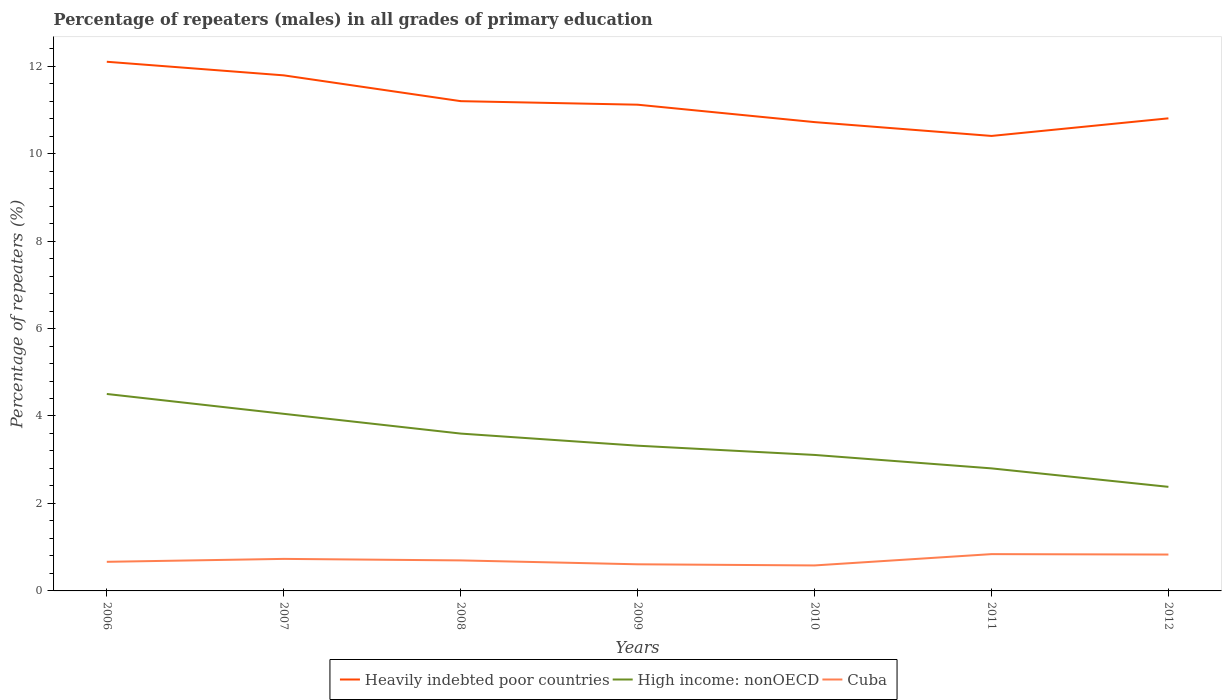Across all years, what is the maximum percentage of repeaters (males) in Cuba?
Your response must be concise. 0.58. In which year was the percentage of repeaters (males) in Cuba maximum?
Provide a short and direct response. 2010. What is the total percentage of repeaters (males) in High income: nonOECD in the graph?
Your answer should be very brief. 1.22. What is the difference between the highest and the second highest percentage of repeaters (males) in Cuba?
Give a very brief answer. 0.26. What is the difference between the highest and the lowest percentage of repeaters (males) in Cuba?
Provide a short and direct response. 3. Is the percentage of repeaters (males) in High income: nonOECD strictly greater than the percentage of repeaters (males) in Heavily indebted poor countries over the years?
Make the answer very short. Yes. Are the values on the major ticks of Y-axis written in scientific E-notation?
Provide a succinct answer. No. Where does the legend appear in the graph?
Your answer should be compact. Bottom center. What is the title of the graph?
Provide a succinct answer. Percentage of repeaters (males) in all grades of primary education. Does "San Marino" appear as one of the legend labels in the graph?
Ensure brevity in your answer.  No. What is the label or title of the X-axis?
Your answer should be compact. Years. What is the label or title of the Y-axis?
Provide a short and direct response. Percentage of repeaters (%). What is the Percentage of repeaters (%) of Heavily indebted poor countries in 2006?
Ensure brevity in your answer.  12.1. What is the Percentage of repeaters (%) in High income: nonOECD in 2006?
Give a very brief answer. 4.5. What is the Percentage of repeaters (%) in Cuba in 2006?
Ensure brevity in your answer.  0.67. What is the Percentage of repeaters (%) in Heavily indebted poor countries in 2007?
Provide a short and direct response. 11.79. What is the Percentage of repeaters (%) of High income: nonOECD in 2007?
Give a very brief answer. 4.05. What is the Percentage of repeaters (%) of Cuba in 2007?
Your answer should be very brief. 0.73. What is the Percentage of repeaters (%) of Heavily indebted poor countries in 2008?
Your answer should be very brief. 11.2. What is the Percentage of repeaters (%) of High income: nonOECD in 2008?
Your response must be concise. 3.6. What is the Percentage of repeaters (%) of Cuba in 2008?
Your answer should be very brief. 0.7. What is the Percentage of repeaters (%) in Heavily indebted poor countries in 2009?
Your answer should be very brief. 11.12. What is the Percentage of repeaters (%) in High income: nonOECD in 2009?
Ensure brevity in your answer.  3.32. What is the Percentage of repeaters (%) in Cuba in 2009?
Ensure brevity in your answer.  0.61. What is the Percentage of repeaters (%) in Heavily indebted poor countries in 2010?
Make the answer very short. 10.72. What is the Percentage of repeaters (%) in High income: nonOECD in 2010?
Give a very brief answer. 3.11. What is the Percentage of repeaters (%) in Cuba in 2010?
Ensure brevity in your answer.  0.58. What is the Percentage of repeaters (%) of Heavily indebted poor countries in 2011?
Give a very brief answer. 10.4. What is the Percentage of repeaters (%) of High income: nonOECD in 2011?
Provide a short and direct response. 2.8. What is the Percentage of repeaters (%) in Cuba in 2011?
Your answer should be very brief. 0.84. What is the Percentage of repeaters (%) in Heavily indebted poor countries in 2012?
Your response must be concise. 10.81. What is the Percentage of repeaters (%) of High income: nonOECD in 2012?
Your answer should be compact. 2.38. What is the Percentage of repeaters (%) in Cuba in 2012?
Provide a short and direct response. 0.83. Across all years, what is the maximum Percentage of repeaters (%) in Heavily indebted poor countries?
Your response must be concise. 12.1. Across all years, what is the maximum Percentage of repeaters (%) of High income: nonOECD?
Offer a terse response. 4.5. Across all years, what is the maximum Percentage of repeaters (%) of Cuba?
Offer a terse response. 0.84. Across all years, what is the minimum Percentage of repeaters (%) in Heavily indebted poor countries?
Your response must be concise. 10.4. Across all years, what is the minimum Percentage of repeaters (%) of High income: nonOECD?
Your response must be concise. 2.38. Across all years, what is the minimum Percentage of repeaters (%) in Cuba?
Give a very brief answer. 0.58. What is the total Percentage of repeaters (%) of Heavily indebted poor countries in the graph?
Make the answer very short. 78.14. What is the total Percentage of repeaters (%) of High income: nonOECD in the graph?
Give a very brief answer. 23.76. What is the total Percentage of repeaters (%) of Cuba in the graph?
Make the answer very short. 4.96. What is the difference between the Percentage of repeaters (%) in Heavily indebted poor countries in 2006 and that in 2007?
Keep it short and to the point. 0.31. What is the difference between the Percentage of repeaters (%) in High income: nonOECD in 2006 and that in 2007?
Ensure brevity in your answer.  0.45. What is the difference between the Percentage of repeaters (%) of Cuba in 2006 and that in 2007?
Your response must be concise. -0.07. What is the difference between the Percentage of repeaters (%) of Heavily indebted poor countries in 2006 and that in 2008?
Provide a succinct answer. 0.9. What is the difference between the Percentage of repeaters (%) of High income: nonOECD in 2006 and that in 2008?
Make the answer very short. 0.91. What is the difference between the Percentage of repeaters (%) in Cuba in 2006 and that in 2008?
Your response must be concise. -0.03. What is the difference between the Percentage of repeaters (%) in Heavily indebted poor countries in 2006 and that in 2009?
Keep it short and to the point. 0.98. What is the difference between the Percentage of repeaters (%) of High income: nonOECD in 2006 and that in 2009?
Your answer should be compact. 1.18. What is the difference between the Percentage of repeaters (%) of Cuba in 2006 and that in 2009?
Your response must be concise. 0.06. What is the difference between the Percentage of repeaters (%) in Heavily indebted poor countries in 2006 and that in 2010?
Your response must be concise. 1.38. What is the difference between the Percentage of repeaters (%) of High income: nonOECD in 2006 and that in 2010?
Offer a terse response. 1.39. What is the difference between the Percentage of repeaters (%) in Cuba in 2006 and that in 2010?
Offer a very short reply. 0.08. What is the difference between the Percentage of repeaters (%) in Heavily indebted poor countries in 2006 and that in 2011?
Give a very brief answer. 1.7. What is the difference between the Percentage of repeaters (%) in High income: nonOECD in 2006 and that in 2011?
Keep it short and to the point. 1.7. What is the difference between the Percentage of repeaters (%) of Cuba in 2006 and that in 2011?
Provide a succinct answer. -0.18. What is the difference between the Percentage of repeaters (%) in Heavily indebted poor countries in 2006 and that in 2012?
Make the answer very short. 1.29. What is the difference between the Percentage of repeaters (%) in High income: nonOECD in 2006 and that in 2012?
Your answer should be very brief. 2.12. What is the difference between the Percentage of repeaters (%) of Cuba in 2006 and that in 2012?
Your response must be concise. -0.17. What is the difference between the Percentage of repeaters (%) of Heavily indebted poor countries in 2007 and that in 2008?
Give a very brief answer. 0.59. What is the difference between the Percentage of repeaters (%) of High income: nonOECD in 2007 and that in 2008?
Keep it short and to the point. 0.45. What is the difference between the Percentage of repeaters (%) of Cuba in 2007 and that in 2008?
Provide a succinct answer. 0.03. What is the difference between the Percentage of repeaters (%) of Heavily indebted poor countries in 2007 and that in 2009?
Give a very brief answer. 0.67. What is the difference between the Percentage of repeaters (%) in High income: nonOECD in 2007 and that in 2009?
Offer a terse response. 0.73. What is the difference between the Percentage of repeaters (%) of Cuba in 2007 and that in 2009?
Provide a succinct answer. 0.12. What is the difference between the Percentage of repeaters (%) of Heavily indebted poor countries in 2007 and that in 2010?
Give a very brief answer. 1.07. What is the difference between the Percentage of repeaters (%) of High income: nonOECD in 2007 and that in 2010?
Give a very brief answer. 0.94. What is the difference between the Percentage of repeaters (%) of Cuba in 2007 and that in 2010?
Make the answer very short. 0.15. What is the difference between the Percentage of repeaters (%) of Heavily indebted poor countries in 2007 and that in 2011?
Provide a succinct answer. 1.39. What is the difference between the Percentage of repeaters (%) of High income: nonOECD in 2007 and that in 2011?
Your answer should be compact. 1.25. What is the difference between the Percentage of repeaters (%) of Cuba in 2007 and that in 2011?
Offer a very short reply. -0.11. What is the difference between the Percentage of repeaters (%) of High income: nonOECD in 2007 and that in 2012?
Your answer should be very brief. 1.67. What is the difference between the Percentage of repeaters (%) of Cuba in 2007 and that in 2012?
Your answer should be compact. -0.1. What is the difference between the Percentage of repeaters (%) in Heavily indebted poor countries in 2008 and that in 2009?
Make the answer very short. 0.08. What is the difference between the Percentage of repeaters (%) of High income: nonOECD in 2008 and that in 2009?
Ensure brevity in your answer.  0.28. What is the difference between the Percentage of repeaters (%) of Cuba in 2008 and that in 2009?
Offer a terse response. 0.09. What is the difference between the Percentage of repeaters (%) of Heavily indebted poor countries in 2008 and that in 2010?
Offer a terse response. 0.48. What is the difference between the Percentage of repeaters (%) of High income: nonOECD in 2008 and that in 2010?
Offer a terse response. 0.49. What is the difference between the Percentage of repeaters (%) in Cuba in 2008 and that in 2010?
Provide a short and direct response. 0.12. What is the difference between the Percentage of repeaters (%) of Heavily indebted poor countries in 2008 and that in 2011?
Offer a terse response. 0.8. What is the difference between the Percentage of repeaters (%) in High income: nonOECD in 2008 and that in 2011?
Ensure brevity in your answer.  0.8. What is the difference between the Percentage of repeaters (%) in Cuba in 2008 and that in 2011?
Give a very brief answer. -0.14. What is the difference between the Percentage of repeaters (%) of Heavily indebted poor countries in 2008 and that in 2012?
Offer a terse response. 0.39. What is the difference between the Percentage of repeaters (%) in High income: nonOECD in 2008 and that in 2012?
Your answer should be compact. 1.22. What is the difference between the Percentage of repeaters (%) in Cuba in 2008 and that in 2012?
Your answer should be very brief. -0.13. What is the difference between the Percentage of repeaters (%) of Heavily indebted poor countries in 2009 and that in 2010?
Your response must be concise. 0.4. What is the difference between the Percentage of repeaters (%) of High income: nonOECD in 2009 and that in 2010?
Keep it short and to the point. 0.21. What is the difference between the Percentage of repeaters (%) of Cuba in 2009 and that in 2010?
Your response must be concise. 0.03. What is the difference between the Percentage of repeaters (%) in Heavily indebted poor countries in 2009 and that in 2011?
Offer a terse response. 0.71. What is the difference between the Percentage of repeaters (%) of High income: nonOECD in 2009 and that in 2011?
Your answer should be compact. 0.52. What is the difference between the Percentage of repeaters (%) in Cuba in 2009 and that in 2011?
Offer a very short reply. -0.23. What is the difference between the Percentage of repeaters (%) in Heavily indebted poor countries in 2009 and that in 2012?
Keep it short and to the point. 0.31. What is the difference between the Percentage of repeaters (%) of High income: nonOECD in 2009 and that in 2012?
Give a very brief answer. 0.94. What is the difference between the Percentage of repeaters (%) in Cuba in 2009 and that in 2012?
Your answer should be very brief. -0.22. What is the difference between the Percentage of repeaters (%) in Heavily indebted poor countries in 2010 and that in 2011?
Offer a terse response. 0.32. What is the difference between the Percentage of repeaters (%) in High income: nonOECD in 2010 and that in 2011?
Offer a very short reply. 0.31. What is the difference between the Percentage of repeaters (%) of Cuba in 2010 and that in 2011?
Your response must be concise. -0.26. What is the difference between the Percentage of repeaters (%) of Heavily indebted poor countries in 2010 and that in 2012?
Your answer should be very brief. -0.09. What is the difference between the Percentage of repeaters (%) of High income: nonOECD in 2010 and that in 2012?
Offer a terse response. 0.73. What is the difference between the Percentage of repeaters (%) of Cuba in 2010 and that in 2012?
Ensure brevity in your answer.  -0.25. What is the difference between the Percentage of repeaters (%) of Heavily indebted poor countries in 2011 and that in 2012?
Offer a terse response. -0.4. What is the difference between the Percentage of repeaters (%) in High income: nonOECD in 2011 and that in 2012?
Provide a short and direct response. 0.42. What is the difference between the Percentage of repeaters (%) in Cuba in 2011 and that in 2012?
Ensure brevity in your answer.  0.01. What is the difference between the Percentage of repeaters (%) in Heavily indebted poor countries in 2006 and the Percentage of repeaters (%) in High income: nonOECD in 2007?
Offer a terse response. 8.05. What is the difference between the Percentage of repeaters (%) of Heavily indebted poor countries in 2006 and the Percentage of repeaters (%) of Cuba in 2007?
Your answer should be very brief. 11.37. What is the difference between the Percentage of repeaters (%) of High income: nonOECD in 2006 and the Percentage of repeaters (%) of Cuba in 2007?
Your response must be concise. 3.77. What is the difference between the Percentage of repeaters (%) in Heavily indebted poor countries in 2006 and the Percentage of repeaters (%) in High income: nonOECD in 2008?
Offer a very short reply. 8.5. What is the difference between the Percentage of repeaters (%) of Heavily indebted poor countries in 2006 and the Percentage of repeaters (%) of Cuba in 2008?
Give a very brief answer. 11.4. What is the difference between the Percentage of repeaters (%) in High income: nonOECD in 2006 and the Percentage of repeaters (%) in Cuba in 2008?
Offer a terse response. 3.81. What is the difference between the Percentage of repeaters (%) in Heavily indebted poor countries in 2006 and the Percentage of repeaters (%) in High income: nonOECD in 2009?
Your response must be concise. 8.78. What is the difference between the Percentage of repeaters (%) of Heavily indebted poor countries in 2006 and the Percentage of repeaters (%) of Cuba in 2009?
Ensure brevity in your answer.  11.49. What is the difference between the Percentage of repeaters (%) in High income: nonOECD in 2006 and the Percentage of repeaters (%) in Cuba in 2009?
Your response must be concise. 3.89. What is the difference between the Percentage of repeaters (%) in Heavily indebted poor countries in 2006 and the Percentage of repeaters (%) in High income: nonOECD in 2010?
Provide a short and direct response. 8.99. What is the difference between the Percentage of repeaters (%) in Heavily indebted poor countries in 2006 and the Percentage of repeaters (%) in Cuba in 2010?
Ensure brevity in your answer.  11.52. What is the difference between the Percentage of repeaters (%) in High income: nonOECD in 2006 and the Percentage of repeaters (%) in Cuba in 2010?
Provide a short and direct response. 3.92. What is the difference between the Percentage of repeaters (%) in Heavily indebted poor countries in 2006 and the Percentage of repeaters (%) in High income: nonOECD in 2011?
Provide a short and direct response. 9.3. What is the difference between the Percentage of repeaters (%) in Heavily indebted poor countries in 2006 and the Percentage of repeaters (%) in Cuba in 2011?
Offer a terse response. 11.26. What is the difference between the Percentage of repeaters (%) of High income: nonOECD in 2006 and the Percentage of repeaters (%) of Cuba in 2011?
Ensure brevity in your answer.  3.66. What is the difference between the Percentage of repeaters (%) of Heavily indebted poor countries in 2006 and the Percentage of repeaters (%) of High income: nonOECD in 2012?
Ensure brevity in your answer.  9.72. What is the difference between the Percentage of repeaters (%) of Heavily indebted poor countries in 2006 and the Percentage of repeaters (%) of Cuba in 2012?
Ensure brevity in your answer.  11.27. What is the difference between the Percentage of repeaters (%) of High income: nonOECD in 2006 and the Percentage of repeaters (%) of Cuba in 2012?
Offer a terse response. 3.67. What is the difference between the Percentage of repeaters (%) in Heavily indebted poor countries in 2007 and the Percentage of repeaters (%) in High income: nonOECD in 2008?
Keep it short and to the point. 8.19. What is the difference between the Percentage of repeaters (%) of Heavily indebted poor countries in 2007 and the Percentage of repeaters (%) of Cuba in 2008?
Provide a succinct answer. 11.09. What is the difference between the Percentage of repeaters (%) in High income: nonOECD in 2007 and the Percentage of repeaters (%) in Cuba in 2008?
Give a very brief answer. 3.35. What is the difference between the Percentage of repeaters (%) of Heavily indebted poor countries in 2007 and the Percentage of repeaters (%) of High income: nonOECD in 2009?
Provide a short and direct response. 8.47. What is the difference between the Percentage of repeaters (%) in Heavily indebted poor countries in 2007 and the Percentage of repeaters (%) in Cuba in 2009?
Your answer should be compact. 11.18. What is the difference between the Percentage of repeaters (%) of High income: nonOECD in 2007 and the Percentage of repeaters (%) of Cuba in 2009?
Ensure brevity in your answer.  3.44. What is the difference between the Percentage of repeaters (%) of Heavily indebted poor countries in 2007 and the Percentage of repeaters (%) of High income: nonOECD in 2010?
Your answer should be very brief. 8.68. What is the difference between the Percentage of repeaters (%) of Heavily indebted poor countries in 2007 and the Percentage of repeaters (%) of Cuba in 2010?
Offer a terse response. 11.21. What is the difference between the Percentage of repeaters (%) of High income: nonOECD in 2007 and the Percentage of repeaters (%) of Cuba in 2010?
Ensure brevity in your answer.  3.47. What is the difference between the Percentage of repeaters (%) of Heavily indebted poor countries in 2007 and the Percentage of repeaters (%) of High income: nonOECD in 2011?
Your answer should be compact. 8.99. What is the difference between the Percentage of repeaters (%) in Heavily indebted poor countries in 2007 and the Percentage of repeaters (%) in Cuba in 2011?
Keep it short and to the point. 10.95. What is the difference between the Percentage of repeaters (%) in High income: nonOECD in 2007 and the Percentage of repeaters (%) in Cuba in 2011?
Make the answer very short. 3.21. What is the difference between the Percentage of repeaters (%) in Heavily indebted poor countries in 2007 and the Percentage of repeaters (%) in High income: nonOECD in 2012?
Provide a short and direct response. 9.41. What is the difference between the Percentage of repeaters (%) of Heavily indebted poor countries in 2007 and the Percentage of repeaters (%) of Cuba in 2012?
Offer a terse response. 10.96. What is the difference between the Percentage of repeaters (%) of High income: nonOECD in 2007 and the Percentage of repeaters (%) of Cuba in 2012?
Keep it short and to the point. 3.22. What is the difference between the Percentage of repeaters (%) of Heavily indebted poor countries in 2008 and the Percentage of repeaters (%) of High income: nonOECD in 2009?
Give a very brief answer. 7.88. What is the difference between the Percentage of repeaters (%) in Heavily indebted poor countries in 2008 and the Percentage of repeaters (%) in Cuba in 2009?
Your response must be concise. 10.59. What is the difference between the Percentage of repeaters (%) of High income: nonOECD in 2008 and the Percentage of repeaters (%) of Cuba in 2009?
Your answer should be very brief. 2.99. What is the difference between the Percentage of repeaters (%) in Heavily indebted poor countries in 2008 and the Percentage of repeaters (%) in High income: nonOECD in 2010?
Offer a very short reply. 8.09. What is the difference between the Percentage of repeaters (%) in Heavily indebted poor countries in 2008 and the Percentage of repeaters (%) in Cuba in 2010?
Provide a short and direct response. 10.62. What is the difference between the Percentage of repeaters (%) of High income: nonOECD in 2008 and the Percentage of repeaters (%) of Cuba in 2010?
Give a very brief answer. 3.02. What is the difference between the Percentage of repeaters (%) of Heavily indebted poor countries in 2008 and the Percentage of repeaters (%) of High income: nonOECD in 2011?
Your answer should be very brief. 8.4. What is the difference between the Percentage of repeaters (%) of Heavily indebted poor countries in 2008 and the Percentage of repeaters (%) of Cuba in 2011?
Your response must be concise. 10.36. What is the difference between the Percentage of repeaters (%) in High income: nonOECD in 2008 and the Percentage of repeaters (%) in Cuba in 2011?
Ensure brevity in your answer.  2.76. What is the difference between the Percentage of repeaters (%) in Heavily indebted poor countries in 2008 and the Percentage of repeaters (%) in High income: nonOECD in 2012?
Provide a succinct answer. 8.82. What is the difference between the Percentage of repeaters (%) of Heavily indebted poor countries in 2008 and the Percentage of repeaters (%) of Cuba in 2012?
Offer a terse response. 10.37. What is the difference between the Percentage of repeaters (%) in High income: nonOECD in 2008 and the Percentage of repeaters (%) in Cuba in 2012?
Provide a short and direct response. 2.77. What is the difference between the Percentage of repeaters (%) of Heavily indebted poor countries in 2009 and the Percentage of repeaters (%) of High income: nonOECD in 2010?
Provide a succinct answer. 8.01. What is the difference between the Percentage of repeaters (%) of Heavily indebted poor countries in 2009 and the Percentage of repeaters (%) of Cuba in 2010?
Your answer should be very brief. 10.54. What is the difference between the Percentage of repeaters (%) of High income: nonOECD in 2009 and the Percentage of repeaters (%) of Cuba in 2010?
Provide a succinct answer. 2.74. What is the difference between the Percentage of repeaters (%) of Heavily indebted poor countries in 2009 and the Percentage of repeaters (%) of High income: nonOECD in 2011?
Your answer should be compact. 8.32. What is the difference between the Percentage of repeaters (%) in Heavily indebted poor countries in 2009 and the Percentage of repeaters (%) in Cuba in 2011?
Offer a very short reply. 10.28. What is the difference between the Percentage of repeaters (%) in High income: nonOECD in 2009 and the Percentage of repeaters (%) in Cuba in 2011?
Offer a very short reply. 2.48. What is the difference between the Percentage of repeaters (%) of Heavily indebted poor countries in 2009 and the Percentage of repeaters (%) of High income: nonOECD in 2012?
Offer a very short reply. 8.74. What is the difference between the Percentage of repeaters (%) of Heavily indebted poor countries in 2009 and the Percentage of repeaters (%) of Cuba in 2012?
Make the answer very short. 10.29. What is the difference between the Percentage of repeaters (%) of High income: nonOECD in 2009 and the Percentage of repeaters (%) of Cuba in 2012?
Give a very brief answer. 2.49. What is the difference between the Percentage of repeaters (%) of Heavily indebted poor countries in 2010 and the Percentage of repeaters (%) of High income: nonOECD in 2011?
Your response must be concise. 7.92. What is the difference between the Percentage of repeaters (%) of Heavily indebted poor countries in 2010 and the Percentage of repeaters (%) of Cuba in 2011?
Your answer should be compact. 9.88. What is the difference between the Percentage of repeaters (%) in High income: nonOECD in 2010 and the Percentage of repeaters (%) in Cuba in 2011?
Offer a terse response. 2.27. What is the difference between the Percentage of repeaters (%) in Heavily indebted poor countries in 2010 and the Percentage of repeaters (%) in High income: nonOECD in 2012?
Make the answer very short. 8.34. What is the difference between the Percentage of repeaters (%) in Heavily indebted poor countries in 2010 and the Percentage of repeaters (%) in Cuba in 2012?
Keep it short and to the point. 9.89. What is the difference between the Percentage of repeaters (%) of High income: nonOECD in 2010 and the Percentage of repeaters (%) of Cuba in 2012?
Your response must be concise. 2.28. What is the difference between the Percentage of repeaters (%) in Heavily indebted poor countries in 2011 and the Percentage of repeaters (%) in High income: nonOECD in 2012?
Ensure brevity in your answer.  8.02. What is the difference between the Percentage of repeaters (%) in Heavily indebted poor countries in 2011 and the Percentage of repeaters (%) in Cuba in 2012?
Your response must be concise. 9.57. What is the difference between the Percentage of repeaters (%) in High income: nonOECD in 2011 and the Percentage of repeaters (%) in Cuba in 2012?
Your response must be concise. 1.97. What is the average Percentage of repeaters (%) of Heavily indebted poor countries per year?
Offer a terse response. 11.16. What is the average Percentage of repeaters (%) of High income: nonOECD per year?
Make the answer very short. 3.39. What is the average Percentage of repeaters (%) in Cuba per year?
Your answer should be compact. 0.71. In the year 2006, what is the difference between the Percentage of repeaters (%) in Heavily indebted poor countries and Percentage of repeaters (%) in High income: nonOECD?
Provide a short and direct response. 7.6. In the year 2006, what is the difference between the Percentage of repeaters (%) in Heavily indebted poor countries and Percentage of repeaters (%) in Cuba?
Provide a short and direct response. 11.43. In the year 2006, what is the difference between the Percentage of repeaters (%) in High income: nonOECD and Percentage of repeaters (%) in Cuba?
Provide a succinct answer. 3.84. In the year 2007, what is the difference between the Percentage of repeaters (%) of Heavily indebted poor countries and Percentage of repeaters (%) of High income: nonOECD?
Offer a terse response. 7.74. In the year 2007, what is the difference between the Percentage of repeaters (%) of Heavily indebted poor countries and Percentage of repeaters (%) of Cuba?
Your answer should be compact. 11.06. In the year 2007, what is the difference between the Percentage of repeaters (%) in High income: nonOECD and Percentage of repeaters (%) in Cuba?
Your answer should be compact. 3.32. In the year 2008, what is the difference between the Percentage of repeaters (%) of Heavily indebted poor countries and Percentage of repeaters (%) of High income: nonOECD?
Make the answer very short. 7.6. In the year 2008, what is the difference between the Percentage of repeaters (%) of Heavily indebted poor countries and Percentage of repeaters (%) of Cuba?
Offer a terse response. 10.5. In the year 2008, what is the difference between the Percentage of repeaters (%) of High income: nonOECD and Percentage of repeaters (%) of Cuba?
Ensure brevity in your answer.  2.9. In the year 2009, what is the difference between the Percentage of repeaters (%) in Heavily indebted poor countries and Percentage of repeaters (%) in High income: nonOECD?
Keep it short and to the point. 7.8. In the year 2009, what is the difference between the Percentage of repeaters (%) of Heavily indebted poor countries and Percentage of repeaters (%) of Cuba?
Provide a succinct answer. 10.51. In the year 2009, what is the difference between the Percentage of repeaters (%) in High income: nonOECD and Percentage of repeaters (%) in Cuba?
Ensure brevity in your answer.  2.71. In the year 2010, what is the difference between the Percentage of repeaters (%) in Heavily indebted poor countries and Percentage of repeaters (%) in High income: nonOECD?
Provide a succinct answer. 7.61. In the year 2010, what is the difference between the Percentage of repeaters (%) of Heavily indebted poor countries and Percentage of repeaters (%) of Cuba?
Offer a very short reply. 10.14. In the year 2010, what is the difference between the Percentage of repeaters (%) in High income: nonOECD and Percentage of repeaters (%) in Cuba?
Give a very brief answer. 2.53. In the year 2011, what is the difference between the Percentage of repeaters (%) of Heavily indebted poor countries and Percentage of repeaters (%) of High income: nonOECD?
Your response must be concise. 7.6. In the year 2011, what is the difference between the Percentage of repeaters (%) in Heavily indebted poor countries and Percentage of repeaters (%) in Cuba?
Provide a succinct answer. 9.56. In the year 2011, what is the difference between the Percentage of repeaters (%) of High income: nonOECD and Percentage of repeaters (%) of Cuba?
Your response must be concise. 1.96. In the year 2012, what is the difference between the Percentage of repeaters (%) in Heavily indebted poor countries and Percentage of repeaters (%) in High income: nonOECD?
Make the answer very short. 8.43. In the year 2012, what is the difference between the Percentage of repeaters (%) in Heavily indebted poor countries and Percentage of repeaters (%) in Cuba?
Offer a terse response. 9.97. In the year 2012, what is the difference between the Percentage of repeaters (%) of High income: nonOECD and Percentage of repeaters (%) of Cuba?
Offer a terse response. 1.55. What is the ratio of the Percentage of repeaters (%) of Heavily indebted poor countries in 2006 to that in 2007?
Your answer should be compact. 1.03. What is the ratio of the Percentage of repeaters (%) of High income: nonOECD in 2006 to that in 2007?
Ensure brevity in your answer.  1.11. What is the ratio of the Percentage of repeaters (%) of Cuba in 2006 to that in 2007?
Your answer should be compact. 0.91. What is the ratio of the Percentage of repeaters (%) of Heavily indebted poor countries in 2006 to that in 2008?
Make the answer very short. 1.08. What is the ratio of the Percentage of repeaters (%) of High income: nonOECD in 2006 to that in 2008?
Offer a very short reply. 1.25. What is the ratio of the Percentage of repeaters (%) in Cuba in 2006 to that in 2008?
Ensure brevity in your answer.  0.95. What is the ratio of the Percentage of repeaters (%) of Heavily indebted poor countries in 2006 to that in 2009?
Your answer should be very brief. 1.09. What is the ratio of the Percentage of repeaters (%) in High income: nonOECD in 2006 to that in 2009?
Keep it short and to the point. 1.36. What is the ratio of the Percentage of repeaters (%) of Cuba in 2006 to that in 2009?
Keep it short and to the point. 1.09. What is the ratio of the Percentage of repeaters (%) of Heavily indebted poor countries in 2006 to that in 2010?
Your answer should be very brief. 1.13. What is the ratio of the Percentage of repeaters (%) of High income: nonOECD in 2006 to that in 2010?
Your answer should be compact. 1.45. What is the ratio of the Percentage of repeaters (%) in Cuba in 2006 to that in 2010?
Your answer should be compact. 1.14. What is the ratio of the Percentage of repeaters (%) in Heavily indebted poor countries in 2006 to that in 2011?
Your response must be concise. 1.16. What is the ratio of the Percentage of repeaters (%) in High income: nonOECD in 2006 to that in 2011?
Provide a succinct answer. 1.61. What is the ratio of the Percentage of repeaters (%) in Cuba in 2006 to that in 2011?
Keep it short and to the point. 0.79. What is the ratio of the Percentage of repeaters (%) of Heavily indebted poor countries in 2006 to that in 2012?
Provide a short and direct response. 1.12. What is the ratio of the Percentage of repeaters (%) in High income: nonOECD in 2006 to that in 2012?
Your answer should be very brief. 1.89. What is the ratio of the Percentage of repeaters (%) of Cuba in 2006 to that in 2012?
Your response must be concise. 0.8. What is the ratio of the Percentage of repeaters (%) of Heavily indebted poor countries in 2007 to that in 2008?
Your answer should be compact. 1.05. What is the ratio of the Percentage of repeaters (%) of High income: nonOECD in 2007 to that in 2008?
Make the answer very short. 1.13. What is the ratio of the Percentage of repeaters (%) of Cuba in 2007 to that in 2008?
Your response must be concise. 1.05. What is the ratio of the Percentage of repeaters (%) of Heavily indebted poor countries in 2007 to that in 2009?
Your answer should be very brief. 1.06. What is the ratio of the Percentage of repeaters (%) of High income: nonOECD in 2007 to that in 2009?
Keep it short and to the point. 1.22. What is the ratio of the Percentage of repeaters (%) of Cuba in 2007 to that in 2009?
Keep it short and to the point. 1.2. What is the ratio of the Percentage of repeaters (%) of Heavily indebted poor countries in 2007 to that in 2010?
Offer a very short reply. 1.1. What is the ratio of the Percentage of repeaters (%) of High income: nonOECD in 2007 to that in 2010?
Your answer should be very brief. 1.3. What is the ratio of the Percentage of repeaters (%) in Cuba in 2007 to that in 2010?
Ensure brevity in your answer.  1.26. What is the ratio of the Percentage of repeaters (%) in Heavily indebted poor countries in 2007 to that in 2011?
Offer a very short reply. 1.13. What is the ratio of the Percentage of repeaters (%) of High income: nonOECD in 2007 to that in 2011?
Your answer should be compact. 1.45. What is the ratio of the Percentage of repeaters (%) in Cuba in 2007 to that in 2011?
Give a very brief answer. 0.87. What is the ratio of the Percentage of repeaters (%) in Heavily indebted poor countries in 2007 to that in 2012?
Your answer should be very brief. 1.09. What is the ratio of the Percentage of repeaters (%) in High income: nonOECD in 2007 to that in 2012?
Keep it short and to the point. 1.7. What is the ratio of the Percentage of repeaters (%) of Cuba in 2007 to that in 2012?
Keep it short and to the point. 0.88. What is the ratio of the Percentage of repeaters (%) in Heavily indebted poor countries in 2008 to that in 2009?
Offer a terse response. 1.01. What is the ratio of the Percentage of repeaters (%) in High income: nonOECD in 2008 to that in 2009?
Provide a succinct answer. 1.08. What is the ratio of the Percentage of repeaters (%) of Cuba in 2008 to that in 2009?
Give a very brief answer. 1.15. What is the ratio of the Percentage of repeaters (%) of Heavily indebted poor countries in 2008 to that in 2010?
Keep it short and to the point. 1.04. What is the ratio of the Percentage of repeaters (%) of High income: nonOECD in 2008 to that in 2010?
Offer a very short reply. 1.16. What is the ratio of the Percentage of repeaters (%) of Cuba in 2008 to that in 2010?
Your answer should be very brief. 1.2. What is the ratio of the Percentage of repeaters (%) of Heavily indebted poor countries in 2008 to that in 2011?
Keep it short and to the point. 1.08. What is the ratio of the Percentage of repeaters (%) in High income: nonOECD in 2008 to that in 2011?
Provide a succinct answer. 1.28. What is the ratio of the Percentage of repeaters (%) of Cuba in 2008 to that in 2011?
Offer a terse response. 0.83. What is the ratio of the Percentage of repeaters (%) in Heavily indebted poor countries in 2008 to that in 2012?
Your answer should be very brief. 1.04. What is the ratio of the Percentage of repeaters (%) of High income: nonOECD in 2008 to that in 2012?
Ensure brevity in your answer.  1.51. What is the ratio of the Percentage of repeaters (%) in Cuba in 2008 to that in 2012?
Your response must be concise. 0.84. What is the ratio of the Percentage of repeaters (%) in Heavily indebted poor countries in 2009 to that in 2010?
Your answer should be compact. 1.04. What is the ratio of the Percentage of repeaters (%) of High income: nonOECD in 2009 to that in 2010?
Offer a very short reply. 1.07. What is the ratio of the Percentage of repeaters (%) of Cuba in 2009 to that in 2010?
Offer a terse response. 1.05. What is the ratio of the Percentage of repeaters (%) of Heavily indebted poor countries in 2009 to that in 2011?
Offer a very short reply. 1.07. What is the ratio of the Percentage of repeaters (%) of High income: nonOECD in 2009 to that in 2011?
Give a very brief answer. 1.19. What is the ratio of the Percentage of repeaters (%) of Cuba in 2009 to that in 2011?
Offer a terse response. 0.72. What is the ratio of the Percentage of repeaters (%) of Heavily indebted poor countries in 2009 to that in 2012?
Offer a very short reply. 1.03. What is the ratio of the Percentage of repeaters (%) of High income: nonOECD in 2009 to that in 2012?
Ensure brevity in your answer.  1.4. What is the ratio of the Percentage of repeaters (%) in Cuba in 2009 to that in 2012?
Give a very brief answer. 0.73. What is the ratio of the Percentage of repeaters (%) of Heavily indebted poor countries in 2010 to that in 2011?
Offer a terse response. 1.03. What is the ratio of the Percentage of repeaters (%) in High income: nonOECD in 2010 to that in 2011?
Keep it short and to the point. 1.11. What is the ratio of the Percentage of repeaters (%) of Cuba in 2010 to that in 2011?
Ensure brevity in your answer.  0.69. What is the ratio of the Percentage of repeaters (%) of Heavily indebted poor countries in 2010 to that in 2012?
Give a very brief answer. 0.99. What is the ratio of the Percentage of repeaters (%) of High income: nonOECD in 2010 to that in 2012?
Provide a short and direct response. 1.31. What is the ratio of the Percentage of repeaters (%) in Cuba in 2010 to that in 2012?
Provide a succinct answer. 0.7. What is the ratio of the Percentage of repeaters (%) in Heavily indebted poor countries in 2011 to that in 2012?
Your response must be concise. 0.96. What is the ratio of the Percentage of repeaters (%) in High income: nonOECD in 2011 to that in 2012?
Provide a succinct answer. 1.18. What is the ratio of the Percentage of repeaters (%) of Cuba in 2011 to that in 2012?
Ensure brevity in your answer.  1.01. What is the difference between the highest and the second highest Percentage of repeaters (%) of Heavily indebted poor countries?
Offer a terse response. 0.31. What is the difference between the highest and the second highest Percentage of repeaters (%) in High income: nonOECD?
Provide a succinct answer. 0.45. What is the difference between the highest and the second highest Percentage of repeaters (%) in Cuba?
Provide a short and direct response. 0.01. What is the difference between the highest and the lowest Percentage of repeaters (%) of Heavily indebted poor countries?
Offer a terse response. 1.7. What is the difference between the highest and the lowest Percentage of repeaters (%) in High income: nonOECD?
Your response must be concise. 2.12. What is the difference between the highest and the lowest Percentage of repeaters (%) of Cuba?
Your response must be concise. 0.26. 